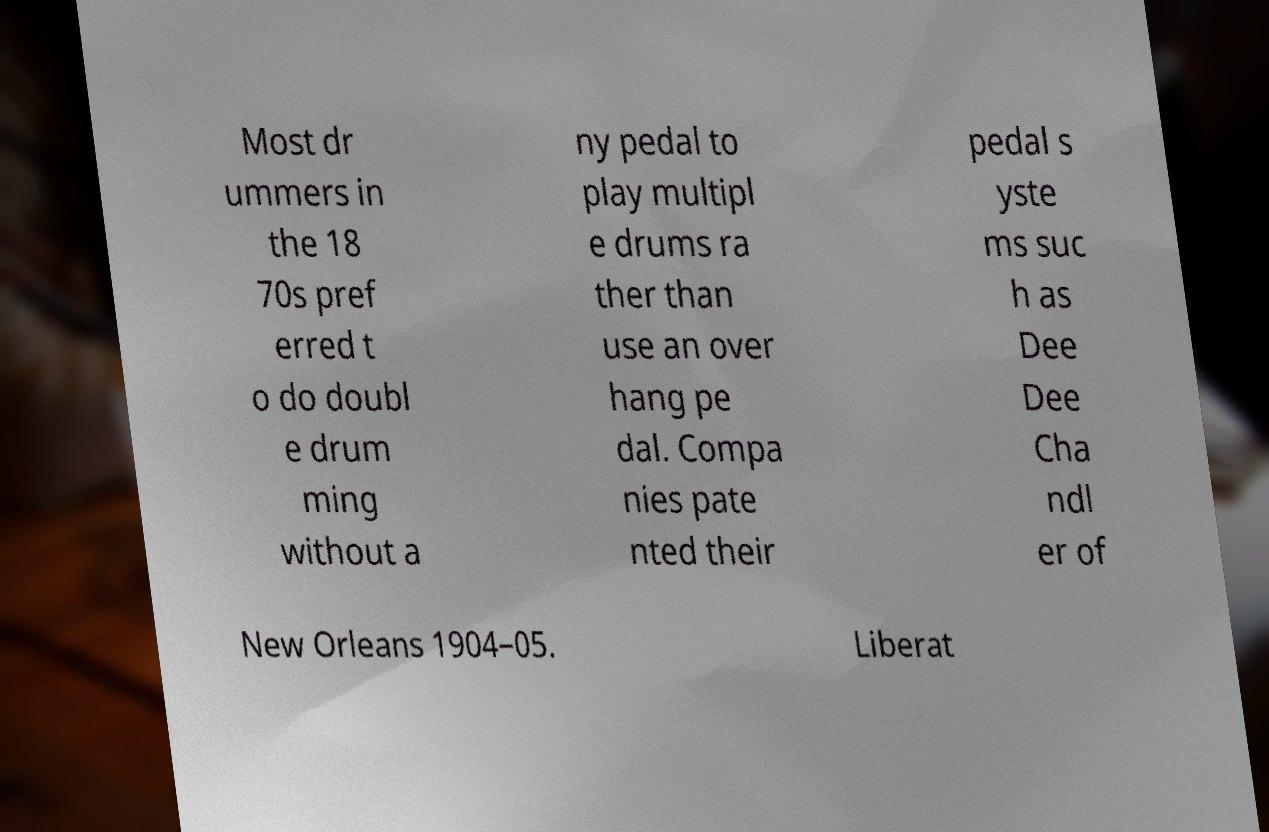For documentation purposes, I need the text within this image transcribed. Could you provide that? Most dr ummers in the 18 70s pref erred t o do doubl e drum ming without a ny pedal to play multipl e drums ra ther than use an over hang pe dal. Compa nies pate nted their pedal s yste ms suc h as Dee Dee Cha ndl er of New Orleans 1904–05. Liberat 